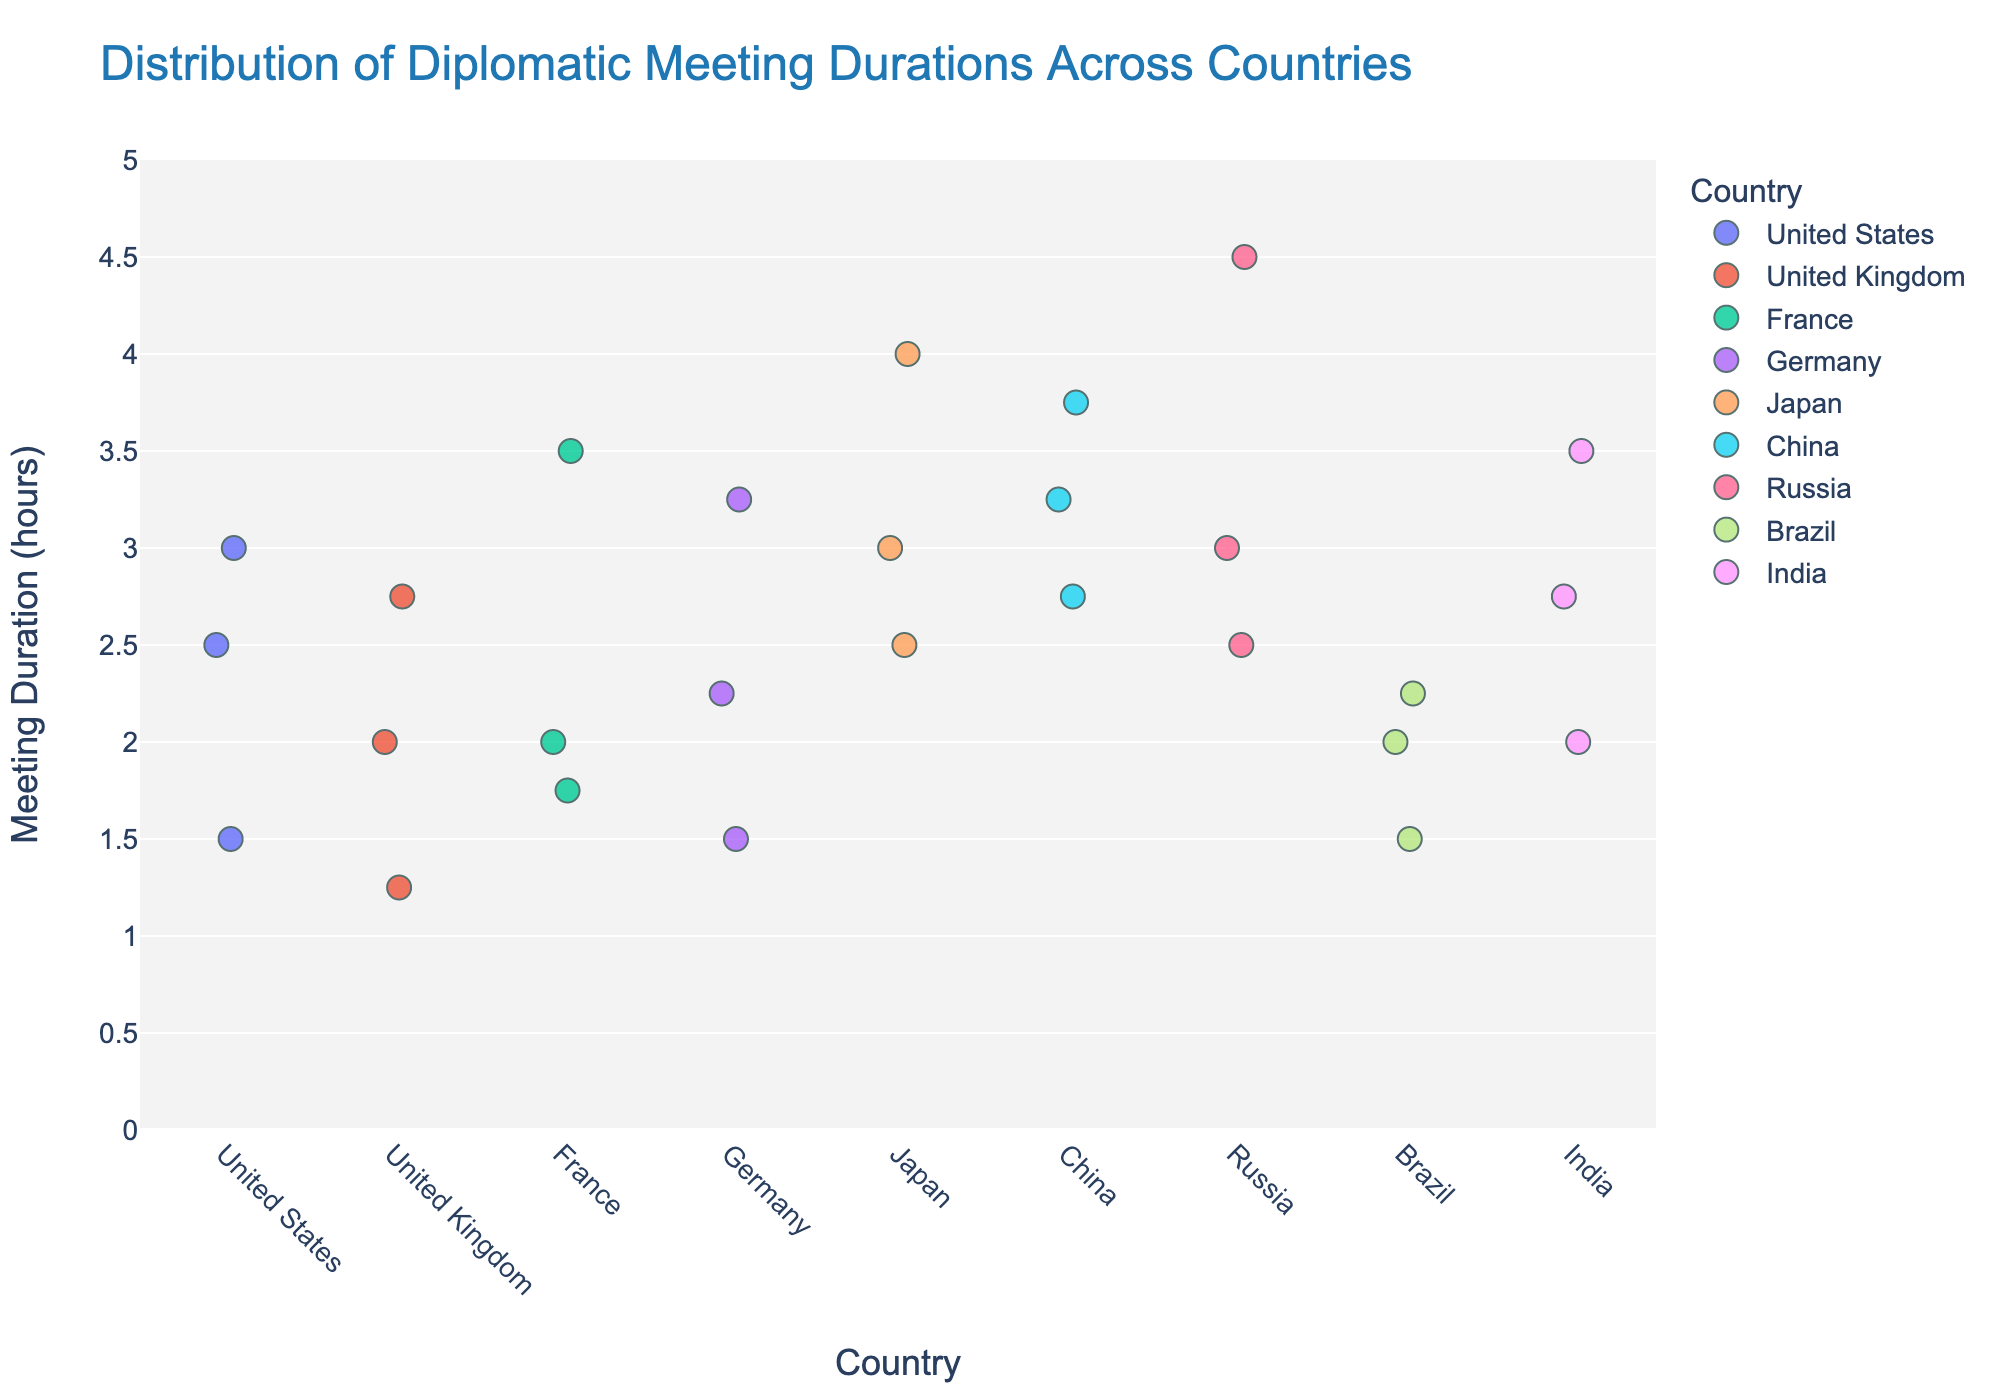Which country has the longest individual diplomatic meeting duration? By examining the plotted points, Russia has a data point at 4.5 hours, which is the highest among all countries.
Answer: Russia What is the title of the figure? The title is located at the top of the figure.
Answer: Distribution of Diplomatic Meeting Durations Across Countries How many data points are there for the United Kingdom? Count the number of points along the vertical strip for the United Kingdom.
Answer: 3 Which country has the shortest meeting duration, and what is that duration? By examining the lowest points in each strip, the United Kingdom has the shortest with a duration of 1.25 hours.
Answer: United Kingdom, 1.25 hours What's the range of meeting durations for Japan? Identify the highest and lowest points along Japan's vertical strip. The highest is 4 hours, and the lowest is 2.5 hours. The range is calculated as 4 - 2.5.
Answer: 1.5 hours Which two countries have meeting durations reaching or exceeding 3.5 hours? Identify strips where meeting points reach or exceed 3.5 hours. France, Japan, China, Russia, and India have meeting durations of at least 3.5 hours.
Answer: France and Russia What is the median meeting duration for Germany? Arrange Germany's meeting durations (1.5, 2.25, 3.25) in ascending order. The median value is the middle value, 2.25.
Answer: 2.25 hours What’s the difference between the longest meeting durations of China and Brazil? The longest meeting duration for China is 3.75 hours, and for Brazil, it is 2.25 hours. Calculate the difference as 3.75 - 2.25.
Answer: 1.5 hours Which country has the most consistent meeting duration (least spread)? By visually examining the cluster tightness, Brazil has the most tightly clustered points around the 2-hour mark.
Answer: Brazil 